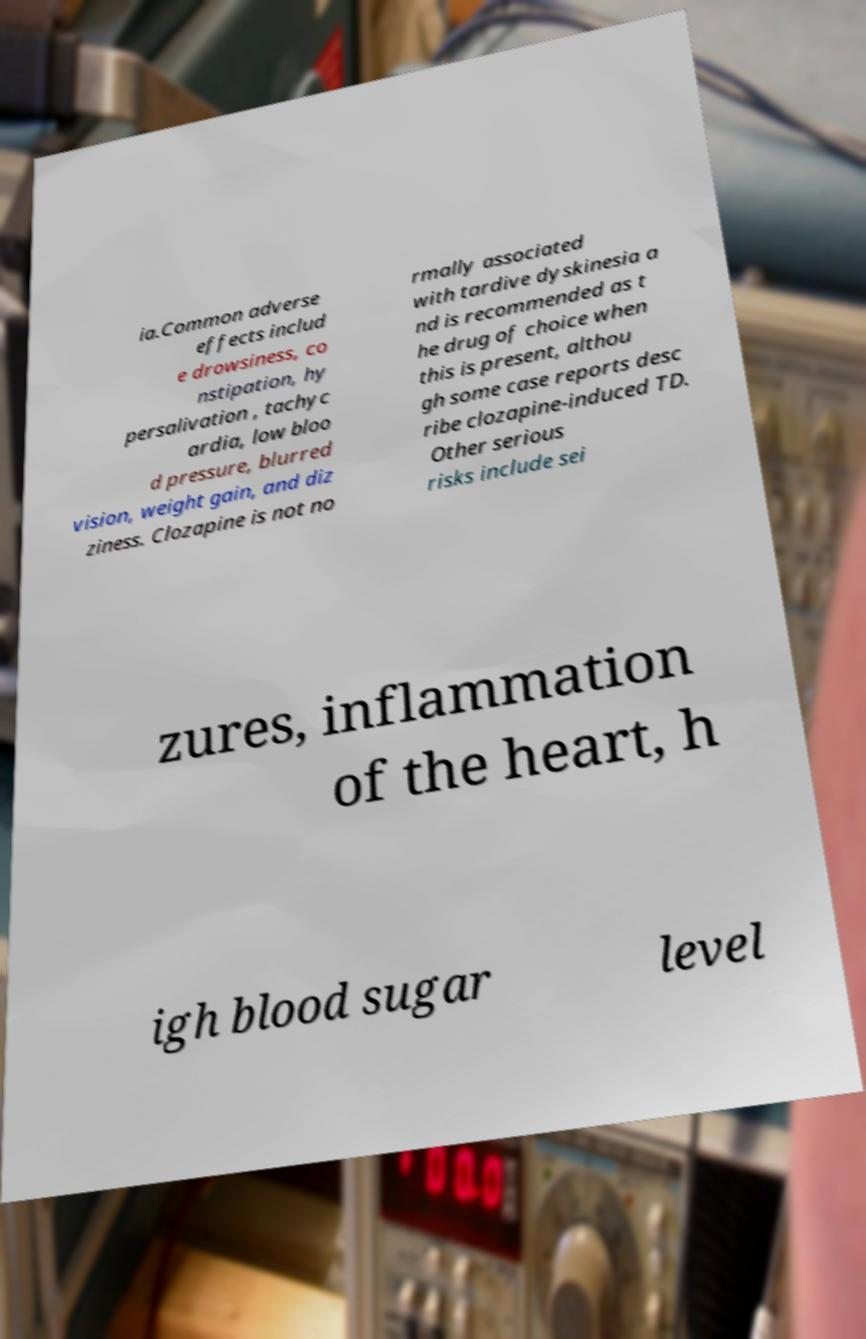Please identify and transcribe the text found in this image. ia.Common adverse effects includ e drowsiness, co nstipation, hy persalivation , tachyc ardia, low bloo d pressure, blurred vision, weight gain, and diz ziness. Clozapine is not no rmally associated with tardive dyskinesia a nd is recommended as t he drug of choice when this is present, althou gh some case reports desc ribe clozapine-induced TD. Other serious risks include sei zures, inflammation of the heart, h igh blood sugar level 